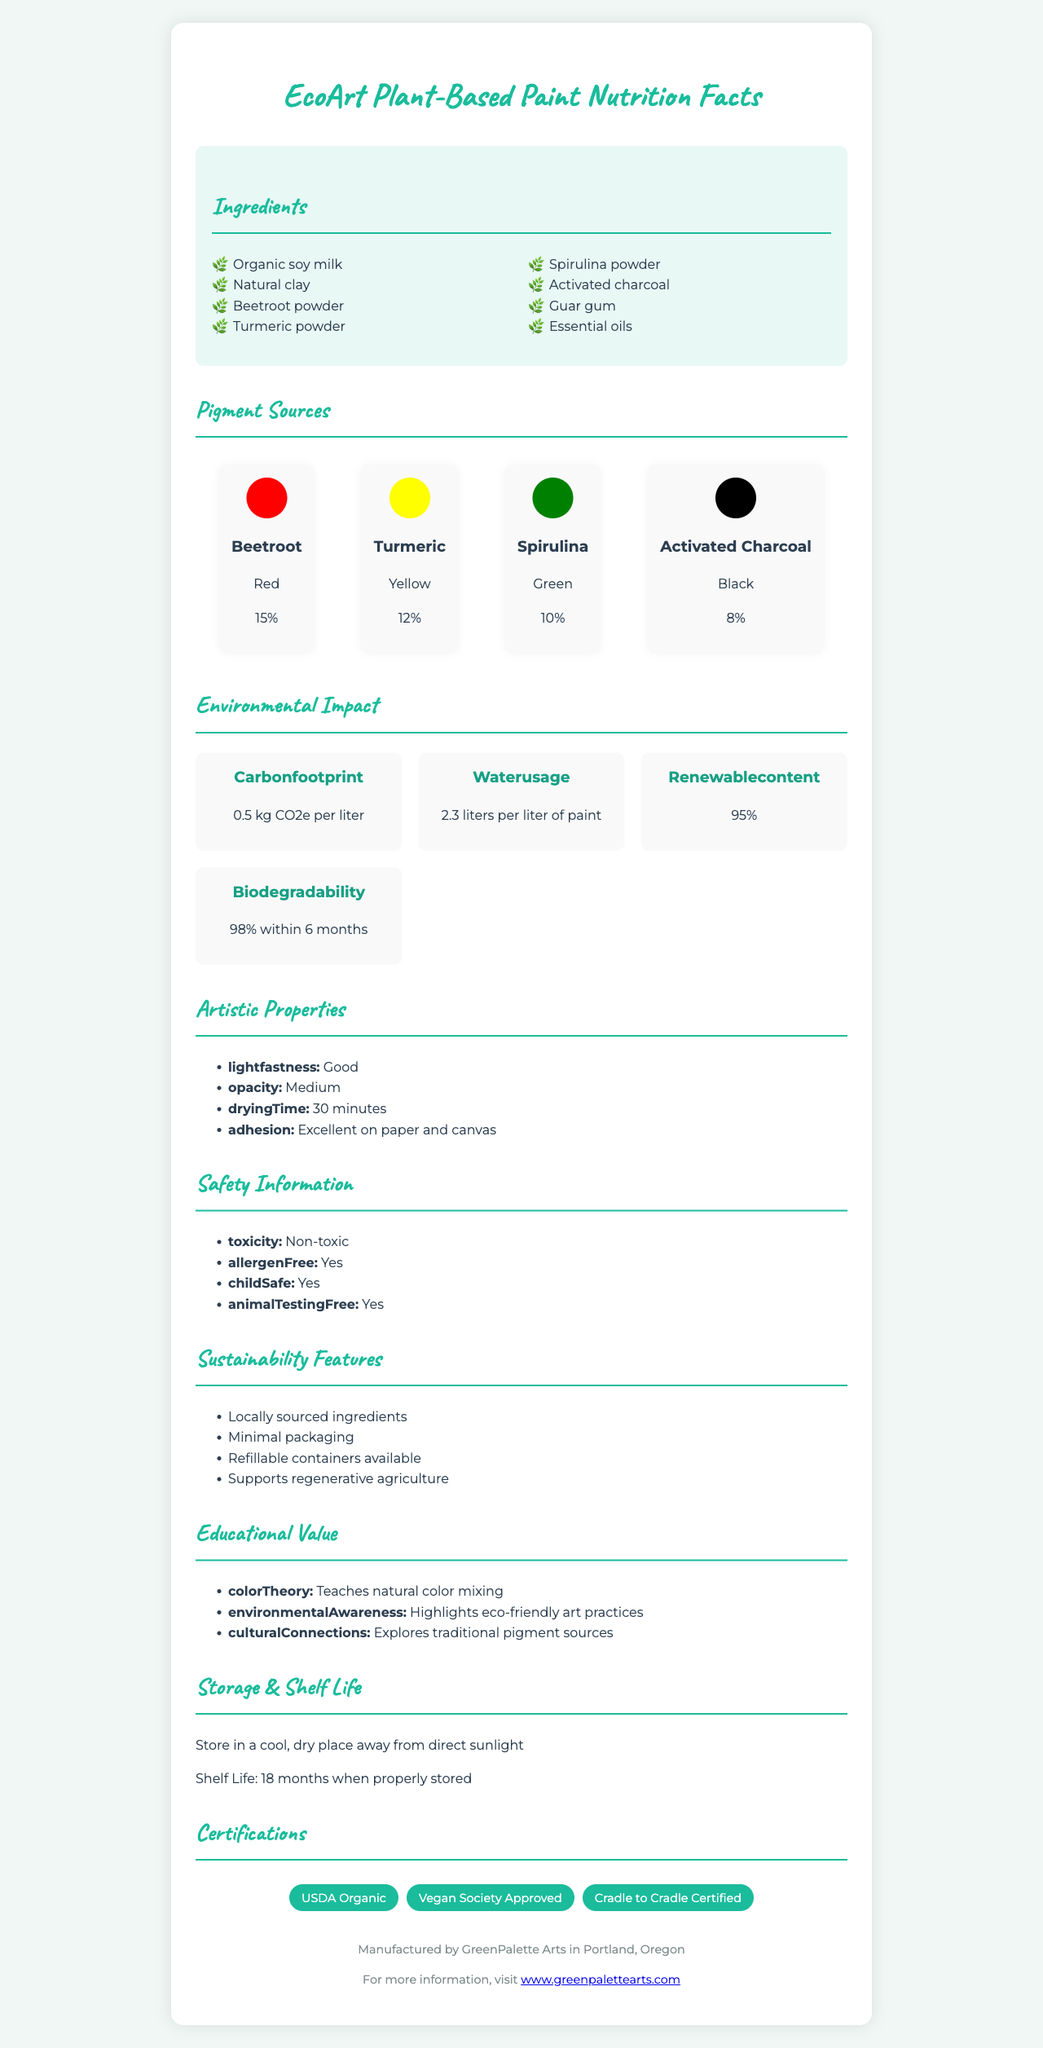what is the serving size? The document specifies the serving size as "30 ml (1 fl oz)".
Answer: 30 ml (1 fl oz) what natural ingredients are used to create the pigments? The pigment sources listed in the document include Beetroot, Turmeric, Spirulina, and Activated Charcoal.
Answer: Beetroot, Turmeric, Spirulina, and Activated Charcoal how long does the paint take to dry? Under the section "Artistic Properties", the drying time is mentioned as "30 minutes".
Answer: 30 minutes what percentage of the paint is from renewable content? The environmental impact section states that the renewable content is "95%".
Answer: 95% what certifications does the product have? The certifications section lists USDA Organic, Vegan Society Approved, and Cradle to Cradle Certified.
Answer: USDA Organic, Vegan Society Approved, Cradle to Cradle Certified what is the main color source for the black pigment? A. Beetroot B. Turmeric C. Spirulina D. Activated Charcoal The document indicates that Activated Charcoal is used for the black pigment with an "8%" contribution.
Answer: D. Activated Charcoal how much water is used per liter of paint? The environmental impact section specifies water usage as "2.3 liters per liter of paint".
Answer: 2.3 liters how many servings are there per container? The document lists the servings per container as "10".
Answer: 10 what is the primary purpose of using essential oils in the paint? A. For fragrance B. For color stabilization C. As a binding agent The document lists essential oils among the ingredients but does not state their purpose explicitly. However, common knowledge suggests that essential oils can act as a binding agent in natural paints.
Answer: C. As a binding agent is the paint toxic? The safety information section explicitly states that the paint is "Non-toxic".
Answer: No does the paint support environmental education? The document mentions that the paint has educational value in color theory, environmental awareness, and cultural connections.
Answer: Yes summarize the main environmental benefits of the EcoArt Plant-Based Paint. This summary captures the main environmental benefits as described in various sections labeled under environmental impact and sustainability features.
Answer: The EcoArt Plant-Based Paint features low carbon footprint, low water usage, high renewable content, and fast biodegradability. Additionally, it uses locally sourced ingredients, minimal packaging, refillable containers, and supports regenerative agriculture. can the paint be used on plastic surfaces? The document only mentions that the paint has excellent adhesion on paper and canvas, with no information regarding plastic surfaces.
Answer: Not enough information 